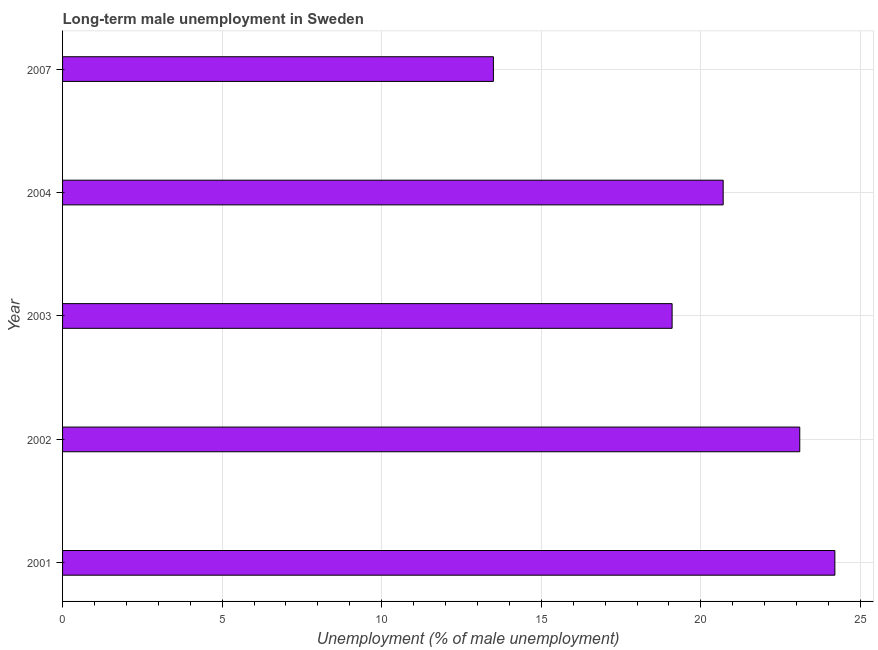What is the title of the graph?
Keep it short and to the point. Long-term male unemployment in Sweden. What is the label or title of the X-axis?
Give a very brief answer. Unemployment (% of male unemployment). What is the long-term male unemployment in 2003?
Offer a very short reply. 19.1. Across all years, what is the maximum long-term male unemployment?
Your response must be concise. 24.2. In which year was the long-term male unemployment maximum?
Provide a short and direct response. 2001. In which year was the long-term male unemployment minimum?
Your answer should be very brief. 2007. What is the sum of the long-term male unemployment?
Ensure brevity in your answer.  100.6. What is the average long-term male unemployment per year?
Keep it short and to the point. 20.12. What is the median long-term male unemployment?
Your answer should be very brief. 20.7. In how many years, is the long-term male unemployment greater than 2 %?
Provide a succinct answer. 5. Do a majority of the years between 2003 and 2001 (inclusive) have long-term male unemployment greater than 5 %?
Offer a terse response. Yes. What is the ratio of the long-term male unemployment in 2001 to that in 2004?
Keep it short and to the point. 1.17. Is the sum of the long-term male unemployment in 2001 and 2004 greater than the maximum long-term male unemployment across all years?
Provide a short and direct response. Yes. In how many years, is the long-term male unemployment greater than the average long-term male unemployment taken over all years?
Give a very brief answer. 3. How many bars are there?
Your answer should be very brief. 5. Are all the bars in the graph horizontal?
Ensure brevity in your answer.  Yes. How many years are there in the graph?
Provide a short and direct response. 5. What is the difference between two consecutive major ticks on the X-axis?
Offer a very short reply. 5. Are the values on the major ticks of X-axis written in scientific E-notation?
Provide a short and direct response. No. What is the Unemployment (% of male unemployment) of 2001?
Your answer should be very brief. 24.2. What is the Unemployment (% of male unemployment) of 2002?
Your answer should be very brief. 23.1. What is the Unemployment (% of male unemployment) in 2003?
Keep it short and to the point. 19.1. What is the Unemployment (% of male unemployment) in 2004?
Provide a short and direct response. 20.7. What is the Unemployment (% of male unemployment) in 2007?
Offer a very short reply. 13.5. What is the difference between the Unemployment (% of male unemployment) in 2001 and 2003?
Give a very brief answer. 5.1. What is the difference between the Unemployment (% of male unemployment) in 2002 and 2003?
Offer a very short reply. 4. What is the difference between the Unemployment (% of male unemployment) in 2003 and 2007?
Your response must be concise. 5.6. What is the ratio of the Unemployment (% of male unemployment) in 2001 to that in 2002?
Ensure brevity in your answer.  1.05. What is the ratio of the Unemployment (% of male unemployment) in 2001 to that in 2003?
Give a very brief answer. 1.27. What is the ratio of the Unemployment (% of male unemployment) in 2001 to that in 2004?
Your answer should be very brief. 1.17. What is the ratio of the Unemployment (% of male unemployment) in 2001 to that in 2007?
Ensure brevity in your answer.  1.79. What is the ratio of the Unemployment (% of male unemployment) in 2002 to that in 2003?
Give a very brief answer. 1.21. What is the ratio of the Unemployment (% of male unemployment) in 2002 to that in 2004?
Ensure brevity in your answer.  1.12. What is the ratio of the Unemployment (% of male unemployment) in 2002 to that in 2007?
Your answer should be compact. 1.71. What is the ratio of the Unemployment (% of male unemployment) in 2003 to that in 2004?
Provide a short and direct response. 0.92. What is the ratio of the Unemployment (% of male unemployment) in 2003 to that in 2007?
Your answer should be very brief. 1.42. What is the ratio of the Unemployment (% of male unemployment) in 2004 to that in 2007?
Your response must be concise. 1.53. 